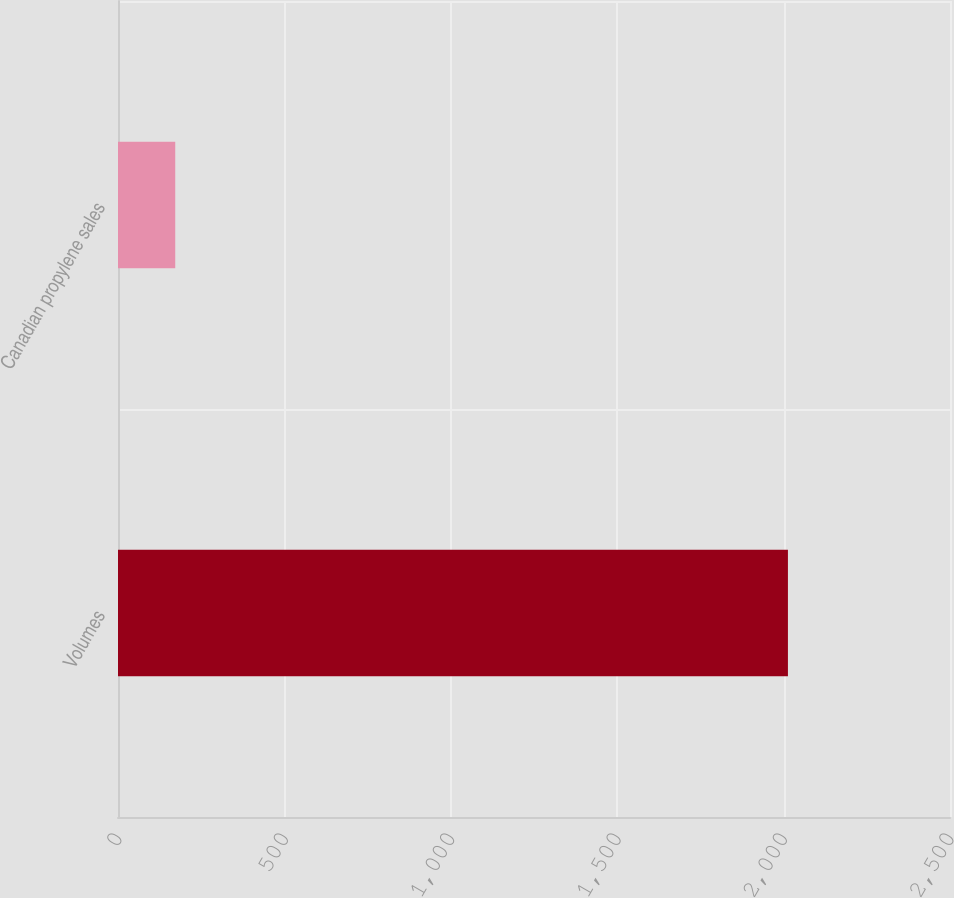Convert chart. <chart><loc_0><loc_0><loc_500><loc_500><bar_chart><fcel>Volumes<fcel>Canadian propylene sales<nl><fcel>2013<fcel>172<nl></chart> 